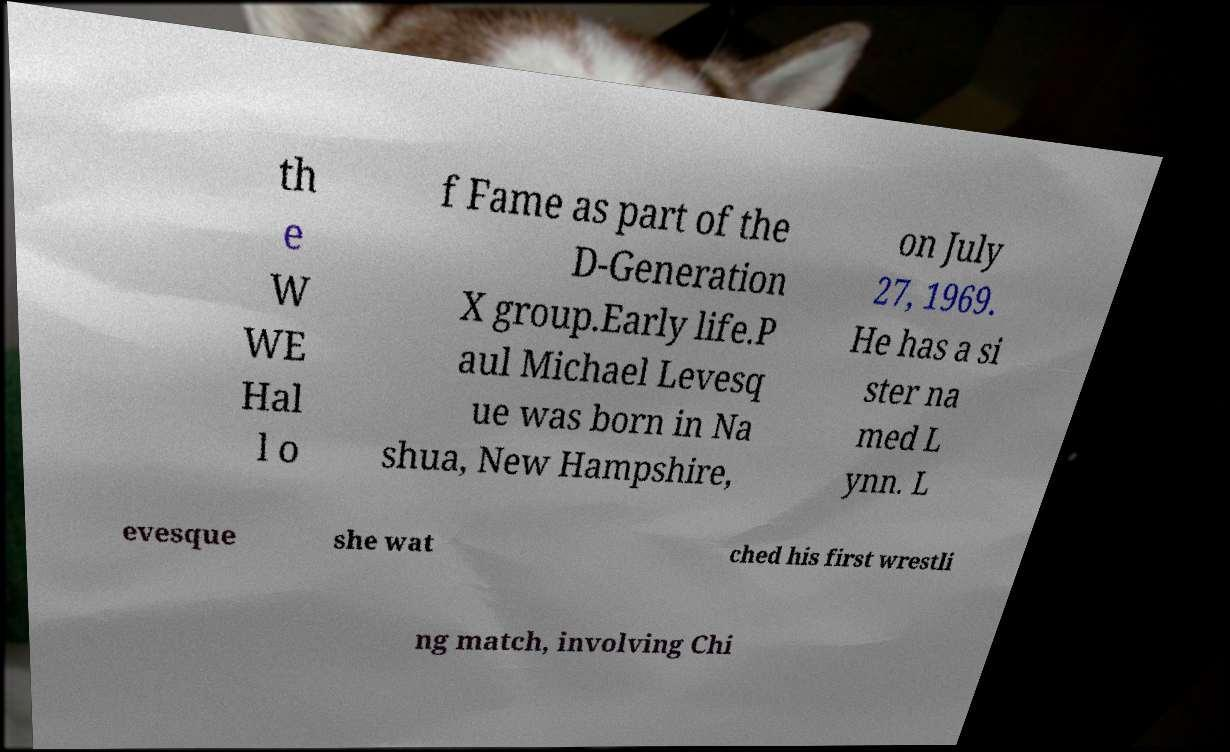Please identify and transcribe the text found in this image. th e W WE Hal l o f Fame as part of the D-Generation X group.Early life.P aul Michael Levesq ue was born in Na shua, New Hampshire, on July 27, 1969. He has a si ster na med L ynn. L evesque she wat ched his first wrestli ng match, involving Chi 